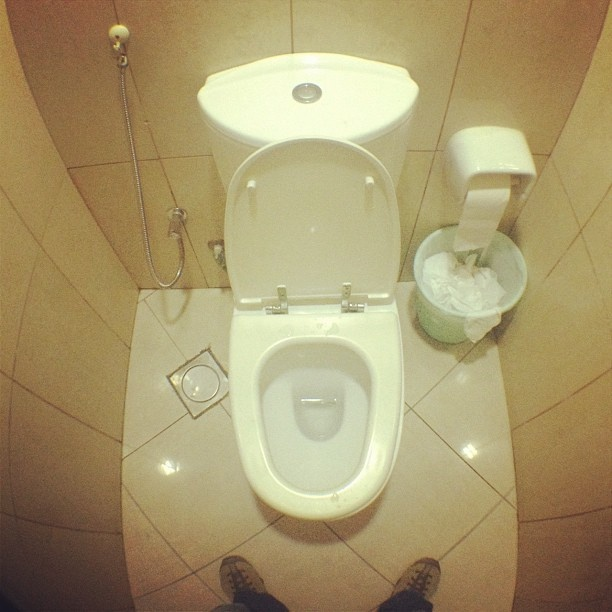Describe the objects in this image and their specific colors. I can see toilet in tan, beige, and lightyellow tones and people in tan, black, maroon, and gray tones in this image. 